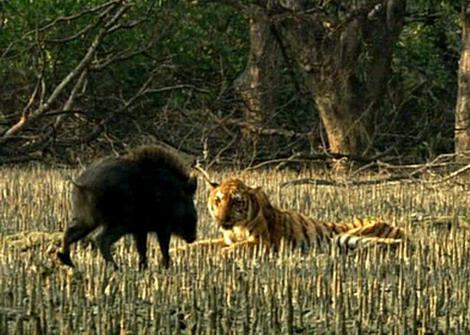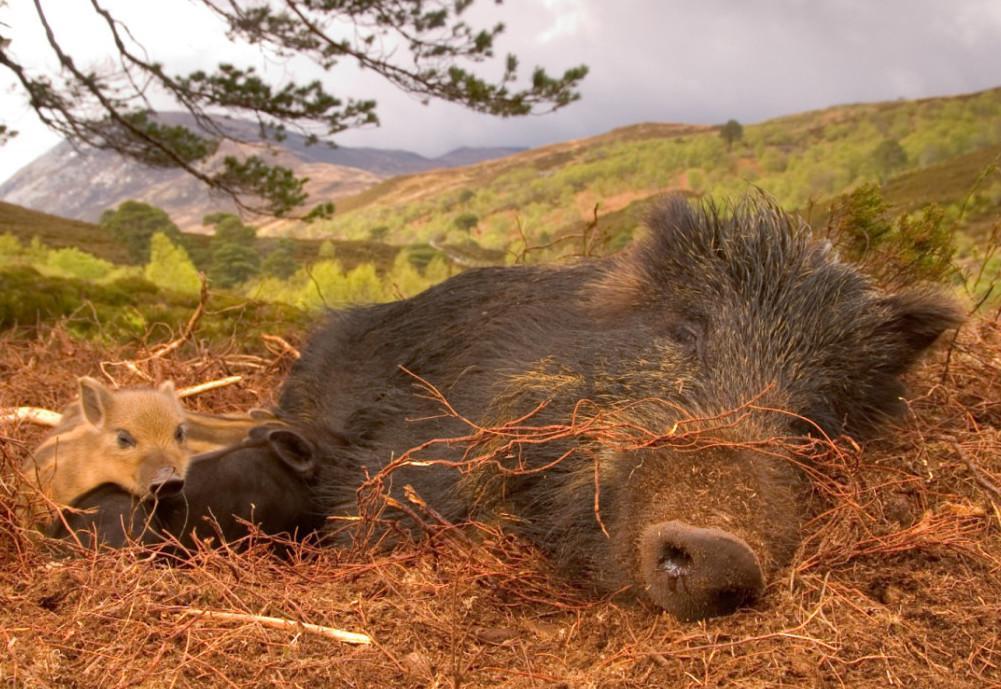The first image is the image on the left, the second image is the image on the right. Assess this claim about the two images: "There is at least one person in one of the photos.". Correct or not? Answer yes or no. No. The first image is the image on the left, the second image is the image on the right. Analyze the images presented: Is the assertion "A pig is on its side." valid? Answer yes or no. Yes. 